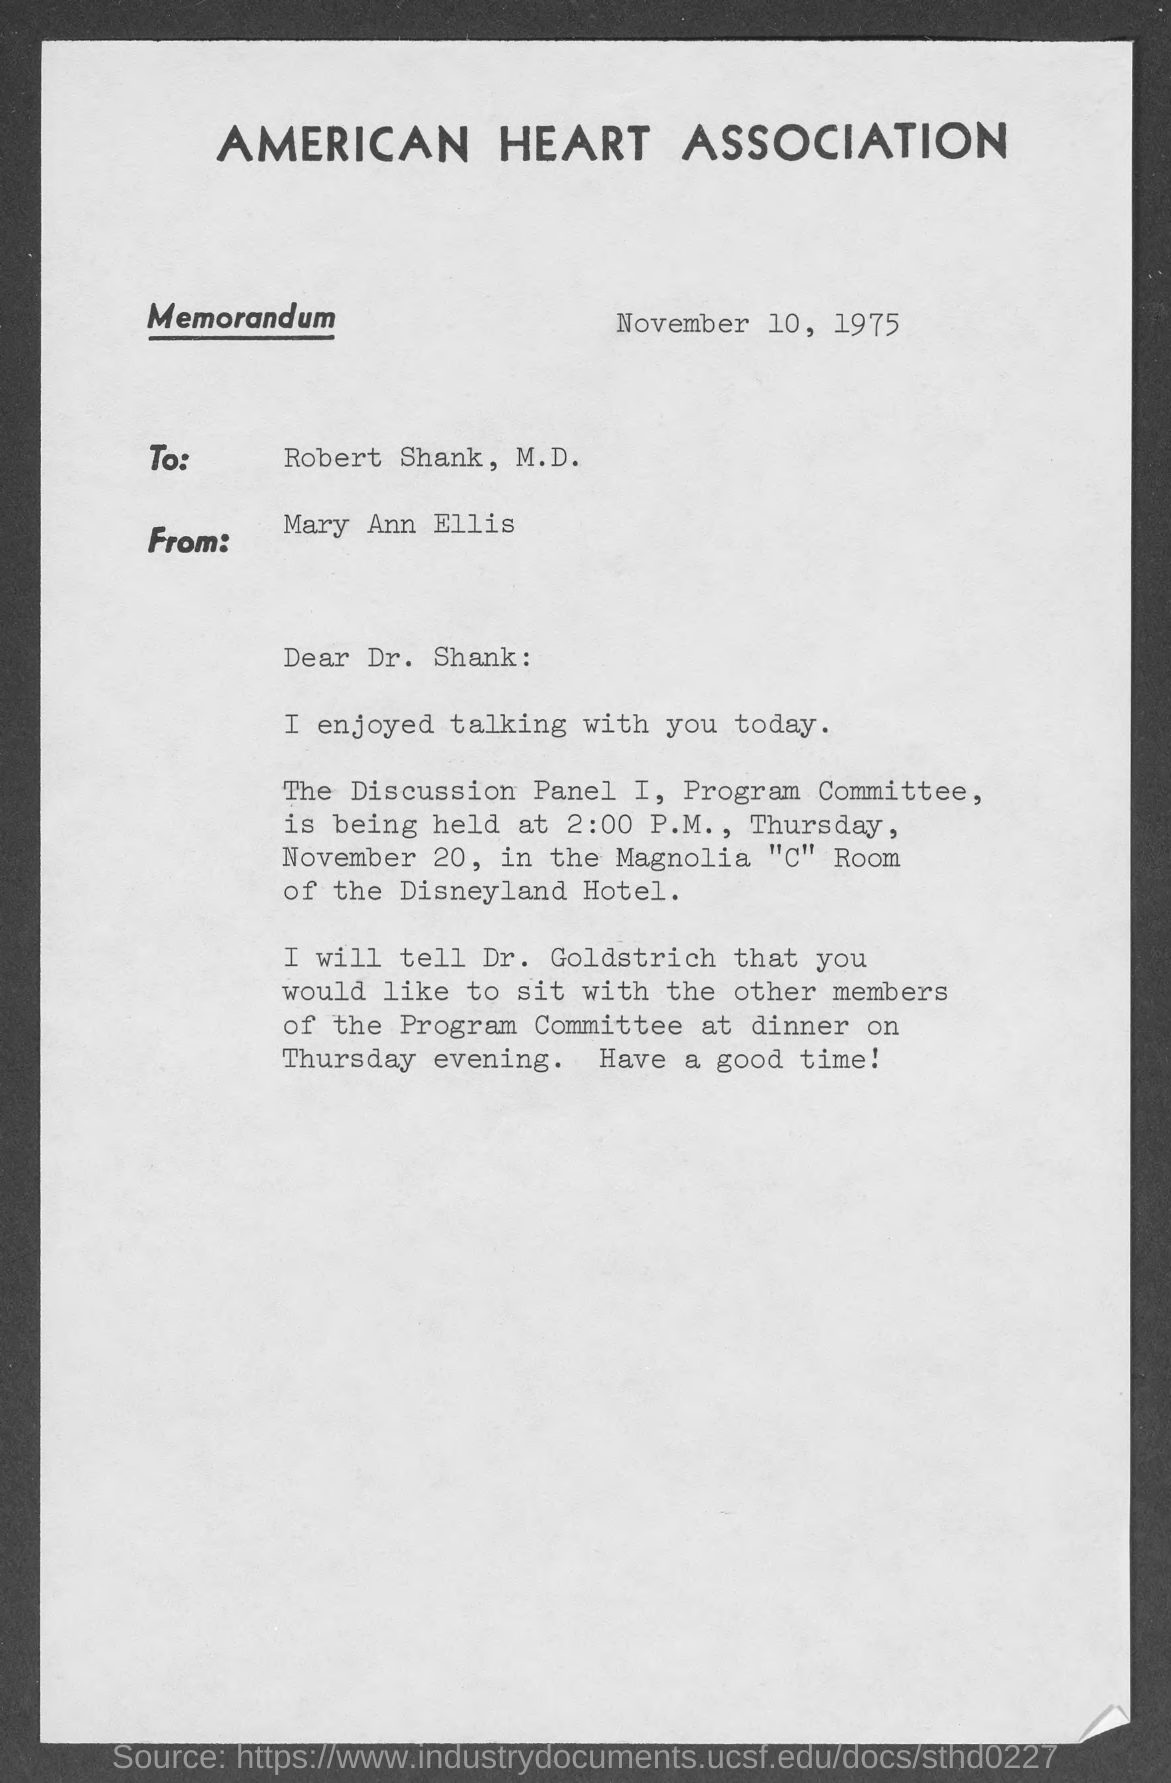What is the name of heart association ?
Ensure brevity in your answer.  American Heart Association. What is the date of issue of the memorandum?
Give a very brief answer. November 10, 1975. To whom is the memorandum written to?
Your answer should be compact. Robert Shank. Who wrote this memorandum ?
Your answer should be compact. Mary Ann Ellis. What is venue for discussion panel i , program committee ?
Give a very brief answer. Magnolia "C" Room of Disneyland Hotel. On what day of the week is program committee is held on?
Make the answer very short. Thursday. At what time would program committee begin?
Your response must be concise. 2:00 P.M. On what day of the week is dinner planned for ?
Keep it short and to the point. Thursday. Dinner plan and discussion with other members of the committee would be told to ?
Offer a terse response. Dr. Goldstrich. What month of the year is mentioned in the page?
Your answer should be very brief. November. 